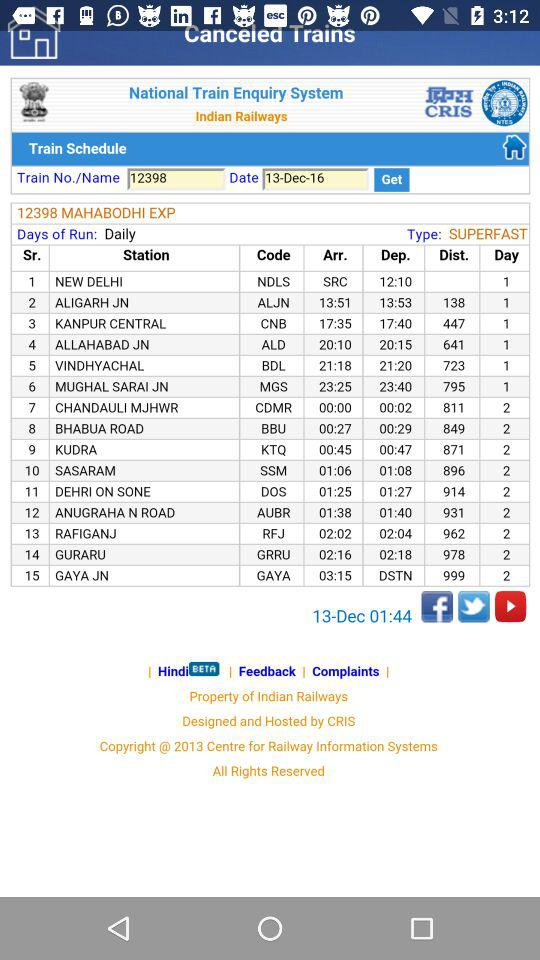What is the train number? The train number is 12398. 